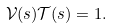<formula> <loc_0><loc_0><loc_500><loc_500>\mathcal { V } ( s ) \mathcal { T } ( s ) = 1 .</formula> 